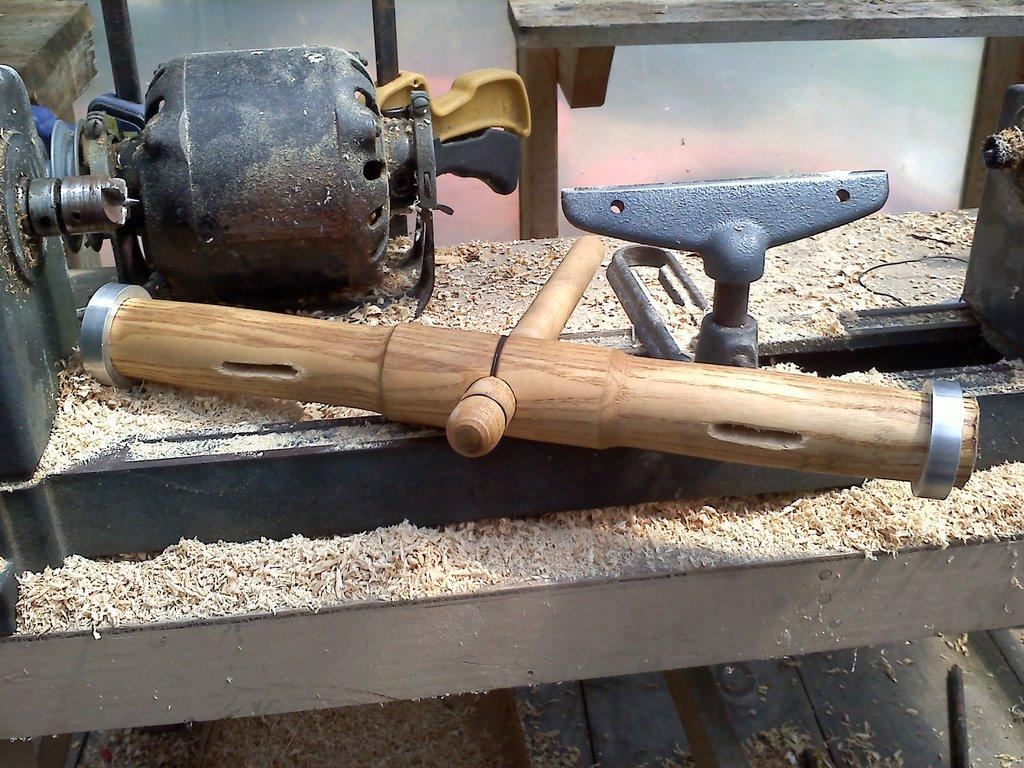What tool is present in the image? There is a hammer in the image. What type of machine is also visible in the image? There is a wood cutting machine in the image. What type of horn can be seen attached to the wood cutting machine in the image? There is no horn present or attached to the wood cutting machine in the image. What material is the brick made of that is being cut by the wood cutting machine in the image? There is no brick present in the image; the wood cutting machine is designed for cutting wood. 